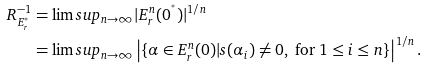<formula> <loc_0><loc_0><loc_500><loc_500>R _ { E ^ { ^ { * } } _ { r } } ^ { - 1 } & = \lim s u p _ { n \to \infty } | E _ { r } ^ { n } ( 0 ^ { ^ { * } } ) | ^ { 1 / n } \\ & = \lim s u p _ { n \to \infty } \left | \{ \alpha \in E _ { r } ^ { n } ( 0 ) | s ( \alpha _ { i } ) \neq 0 , \text { for } 1 \leq i \leq n \} \right | ^ { 1 / n } .</formula> 